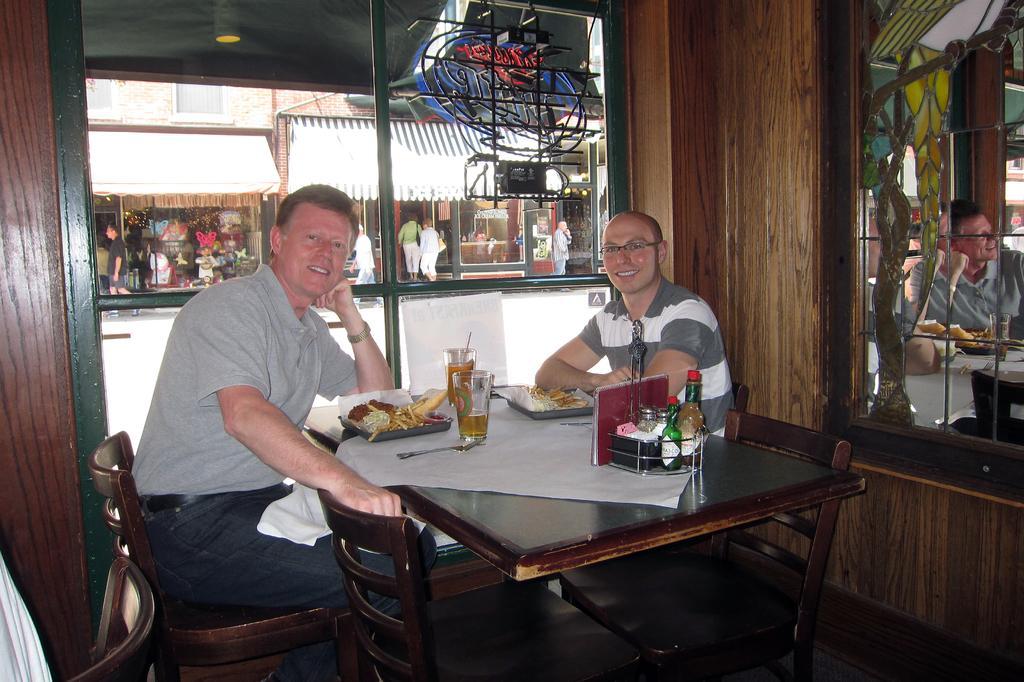Describe this image in one or two sentences. In this image in front two persons in front are sitting on chairs before table having plate served with the food and glasses having drinks inside it and book, spoon. At the background of the image there are few shops. At the left a person is walking. In the middle two persons are walking inside the shop. 